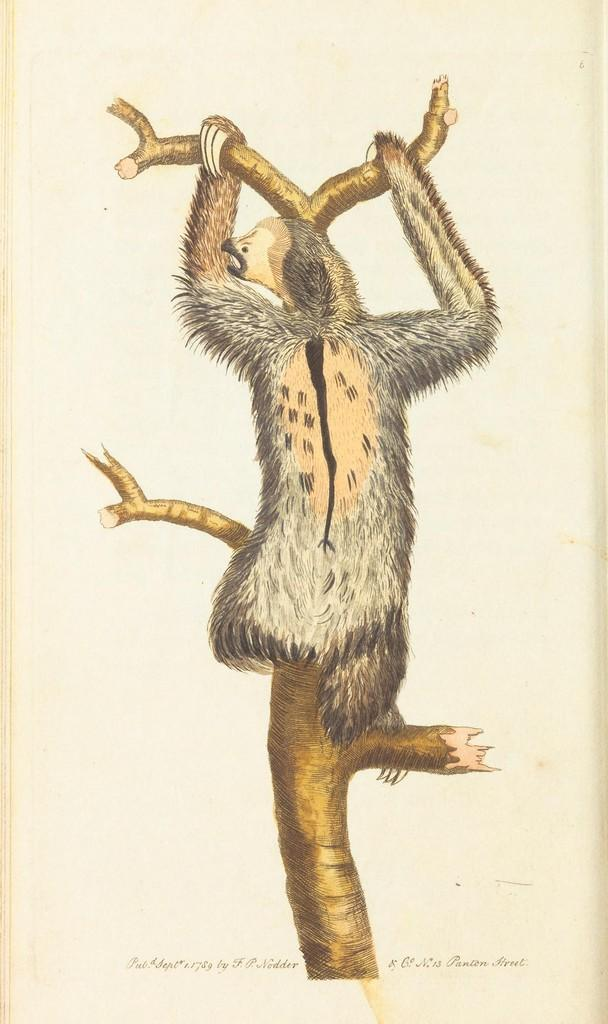What type of animal can be seen on the trunk of a tree in the image? There is an animal visible on the trunk of a tree in the image. Can you describe the text at the bottom of the image? There is text at the bottom of the image, which may resemble a poster. How many ghosts can be seen interacting with the horse in the image? There are no ghosts or horses present in the image; it features an animal on a tree trunk and text at the bottom. 